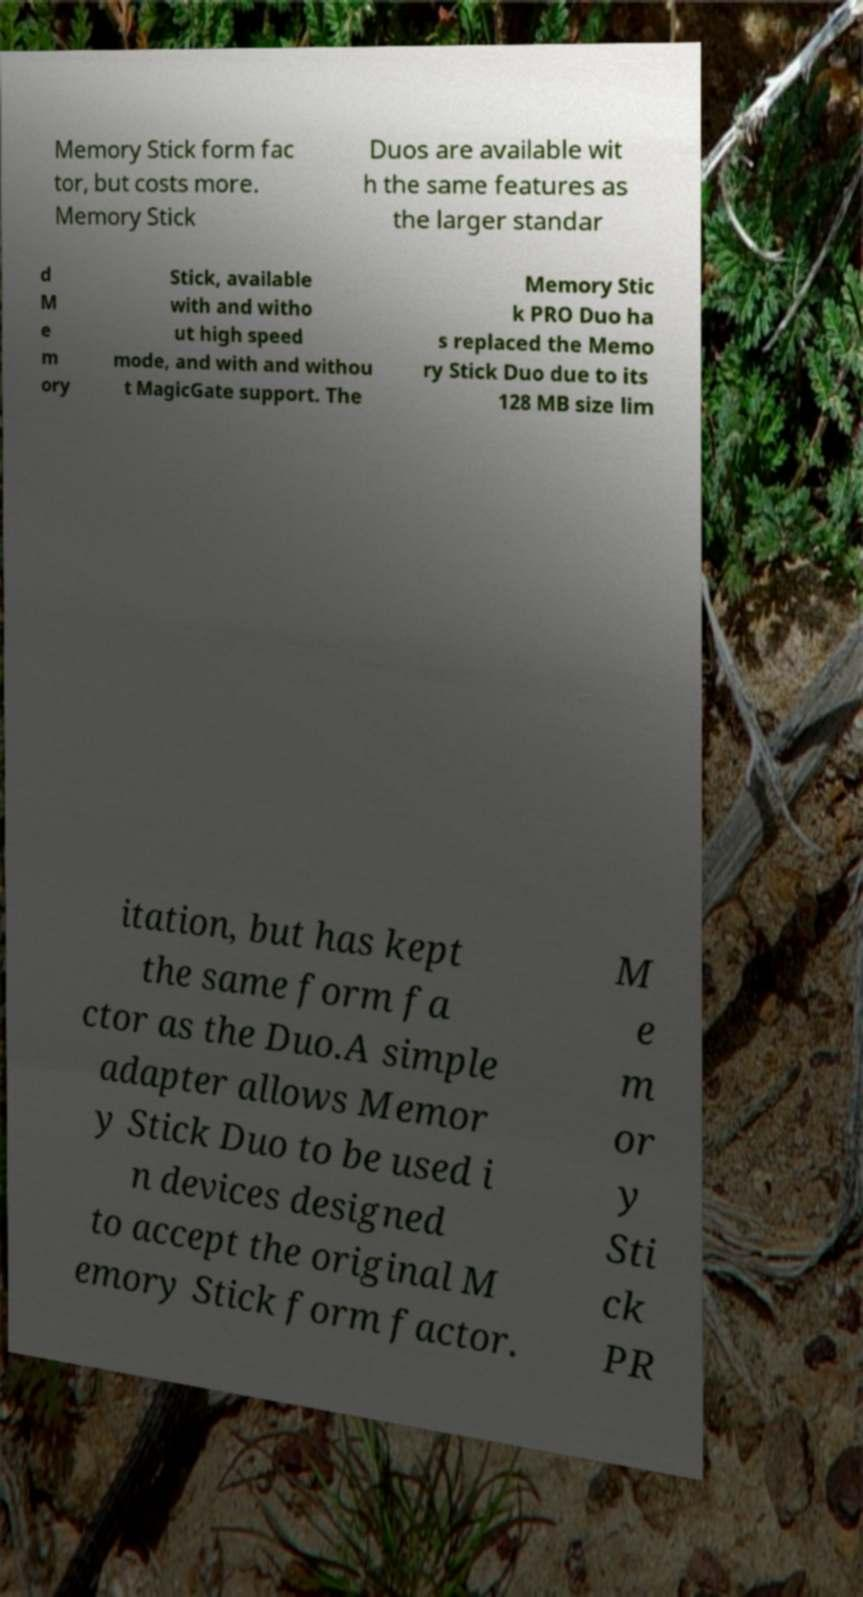Please identify and transcribe the text found in this image. Memory Stick form fac tor, but costs more. Memory Stick Duos are available wit h the same features as the larger standar d M e m ory Stick, available with and witho ut high speed mode, and with and withou t MagicGate support. The Memory Stic k PRO Duo ha s replaced the Memo ry Stick Duo due to its 128 MB size lim itation, but has kept the same form fa ctor as the Duo.A simple adapter allows Memor y Stick Duo to be used i n devices designed to accept the original M emory Stick form factor. M e m or y Sti ck PR 